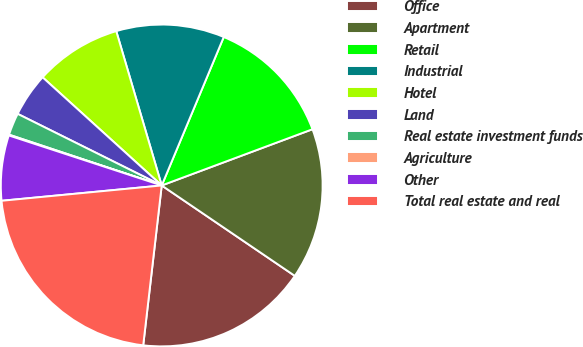Convert chart to OTSL. <chart><loc_0><loc_0><loc_500><loc_500><pie_chart><fcel>Office<fcel>Apartment<fcel>Retail<fcel>Industrial<fcel>Hotel<fcel>Land<fcel>Real estate investment funds<fcel>Agriculture<fcel>Other<fcel>Total real estate and real<nl><fcel>17.34%<fcel>15.18%<fcel>13.02%<fcel>10.86%<fcel>8.71%<fcel>4.39%<fcel>2.23%<fcel>0.08%<fcel>6.55%<fcel>21.65%<nl></chart> 